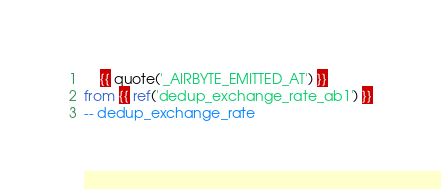Convert code to text. <code><loc_0><loc_0><loc_500><loc_500><_SQL_>    {{ quote('_AIRBYTE_EMITTED_AT') }}
from {{ ref('dedup_exchange_rate_ab1') }}
-- dedup_exchange_rate

</code> 